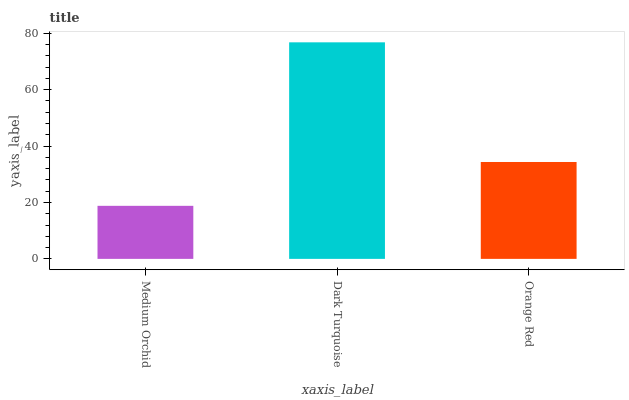Is Medium Orchid the minimum?
Answer yes or no. Yes. Is Dark Turquoise the maximum?
Answer yes or no. Yes. Is Orange Red the minimum?
Answer yes or no. No. Is Orange Red the maximum?
Answer yes or no. No. Is Dark Turquoise greater than Orange Red?
Answer yes or no. Yes. Is Orange Red less than Dark Turquoise?
Answer yes or no. Yes. Is Orange Red greater than Dark Turquoise?
Answer yes or no. No. Is Dark Turquoise less than Orange Red?
Answer yes or no. No. Is Orange Red the high median?
Answer yes or no. Yes. Is Orange Red the low median?
Answer yes or no. Yes. Is Dark Turquoise the high median?
Answer yes or no. No. Is Dark Turquoise the low median?
Answer yes or no. No. 